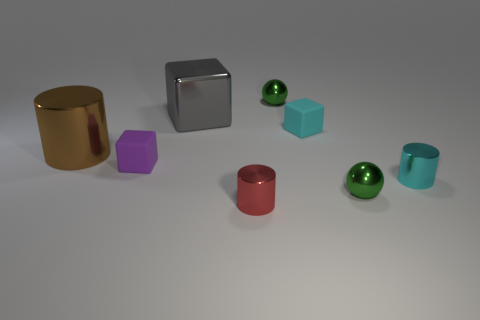There is a object that is both in front of the big brown shiny cylinder and to the left of the red cylinder; what is its material?
Offer a terse response. Rubber. How many objects are small cubes that are behind the brown object or brown metallic cubes?
Keep it short and to the point. 1. Is the big metallic cylinder the same color as the large shiny cube?
Your answer should be compact. No. Is there a green object that has the same size as the purple rubber cube?
Your response must be concise. Yes. What number of cylinders are both left of the tiny cyan shiny cylinder and right of the large gray metal cube?
Your answer should be compact. 1. How many cylinders are to the left of the small red metal thing?
Offer a very short reply. 1. Are there any tiny gray things of the same shape as the purple object?
Provide a short and direct response. No. Do the cyan shiny object and the tiny cyan thing that is behind the cyan shiny object have the same shape?
Offer a very short reply. No. How many cylinders are either tiny green objects or brown shiny objects?
Provide a succinct answer. 1. There is a tiny thing that is to the left of the red metal thing; what is its shape?
Your answer should be compact. Cube. 